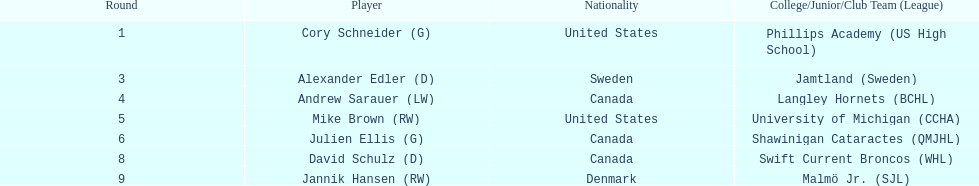List solely the american participants. Cory Schneider (G), Mike Brown (RW). 